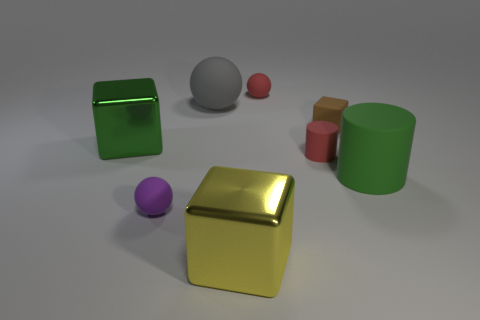What size is the object that is both in front of the red cylinder and to the left of the big gray ball?
Your answer should be very brief. Small. There is a tiny matte object that is on the left side of the red cylinder and behind the large green cube; what is its shape?
Offer a terse response. Sphere. Are there any shiny cubes that are in front of the small red matte thing that is in front of the small matte sphere right of the yellow thing?
Keep it short and to the point. Yes. What number of objects are either green cubes that are to the left of the tiny rubber cube or small matte things on the left side of the rubber cube?
Offer a terse response. 4. Are the green thing left of the tiny red ball and the large yellow cube made of the same material?
Ensure brevity in your answer.  Yes. What is the material of the big thing that is both in front of the large rubber ball and on the left side of the big yellow shiny thing?
Your answer should be compact. Metal. There is a large matte thing that is in front of the cube to the right of the big yellow metallic block; what is its color?
Offer a very short reply. Green. There is a green thing that is the same shape as the tiny brown object; what is it made of?
Your response must be concise. Metal. What color is the shiny thing behind the rubber ball to the left of the large matte object on the left side of the big yellow cube?
Your answer should be compact. Green. How many things are brown things or big brown cubes?
Ensure brevity in your answer.  1. 